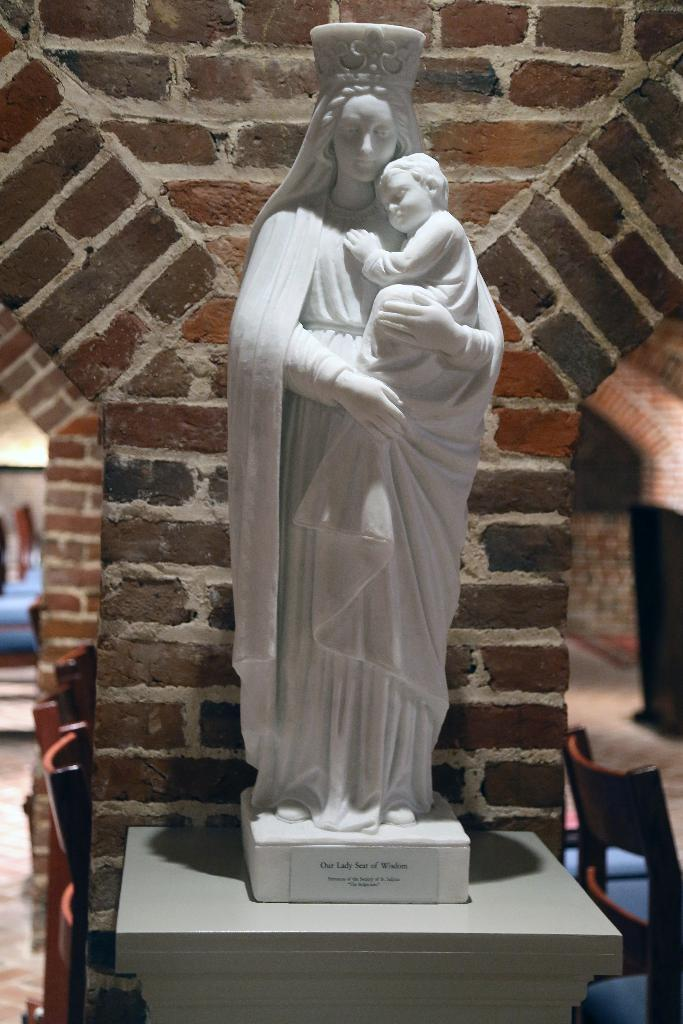What is the main subject in the image? There is a statue in the image. How is the statue positioned in the image? The statue is on a pedestal. What type of structure can be seen in the image? There are walls visible in the image. What type of furniture is present in the image? Chairs are present in the image. What is visible beneath the statue and chairs? The floor is visible in the image. How does the statue maintain its quiet demeanor in the image? The statue does not have a demeanor, as it is an inanimate object. Additionally, the concept of "quiet" does not apply to a statue. 